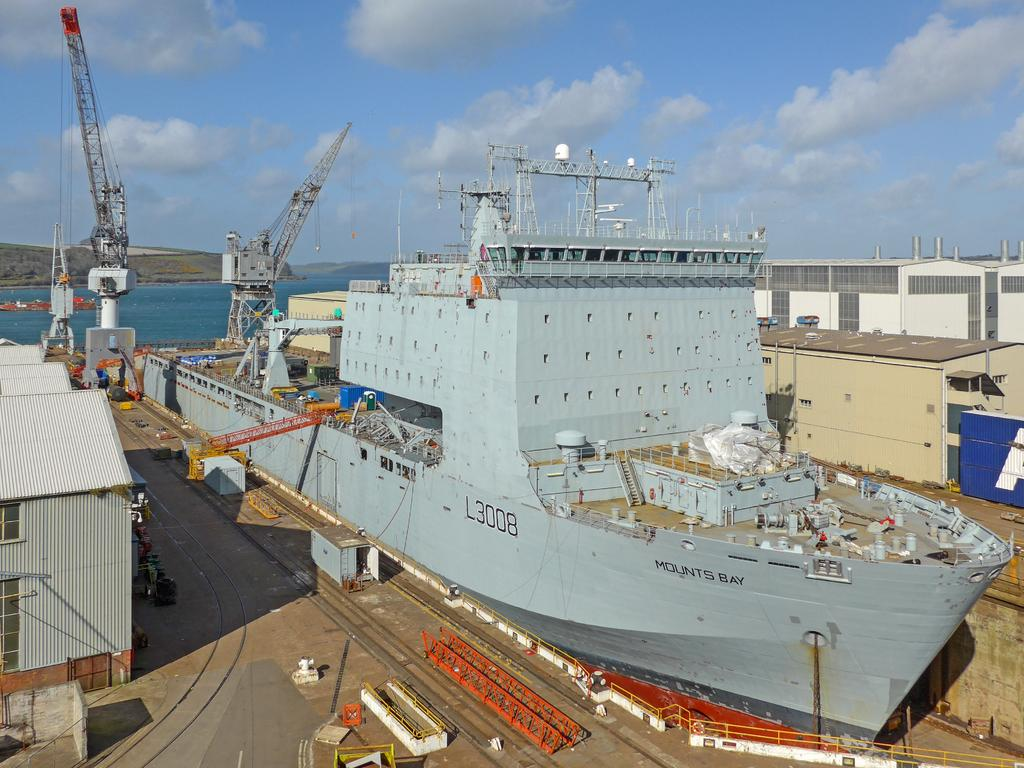What is the main subject of the image? The main subject of the image is a ship. What other structures or objects can be seen in the image? There is a shed, cranes, houses, a building, objects on the surface of the water, and an object above the water in the background. What is the landscape like in the background? In the background, there is a hill, an object above the water, and the sky with clouds is visible. What type of shoes can be seen on the ship in the image? There are no shoes visible on the ship in the image. What type of treatment is being administered to the building in the image? There is no treatment being administered to the building in the image; it is a static structure. What is the oven used for in the image? There is no oven present in the image. 